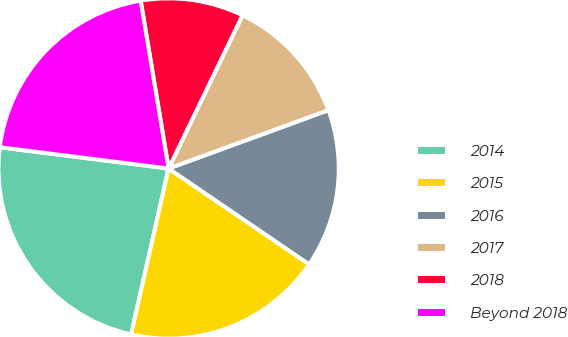Convert chart to OTSL. <chart><loc_0><loc_0><loc_500><loc_500><pie_chart><fcel>2014<fcel>2015<fcel>2016<fcel>2017<fcel>2018<fcel>Beyond 2018<nl><fcel>23.46%<fcel>19.01%<fcel>15.1%<fcel>12.27%<fcel>9.78%<fcel>20.38%<nl></chart> 